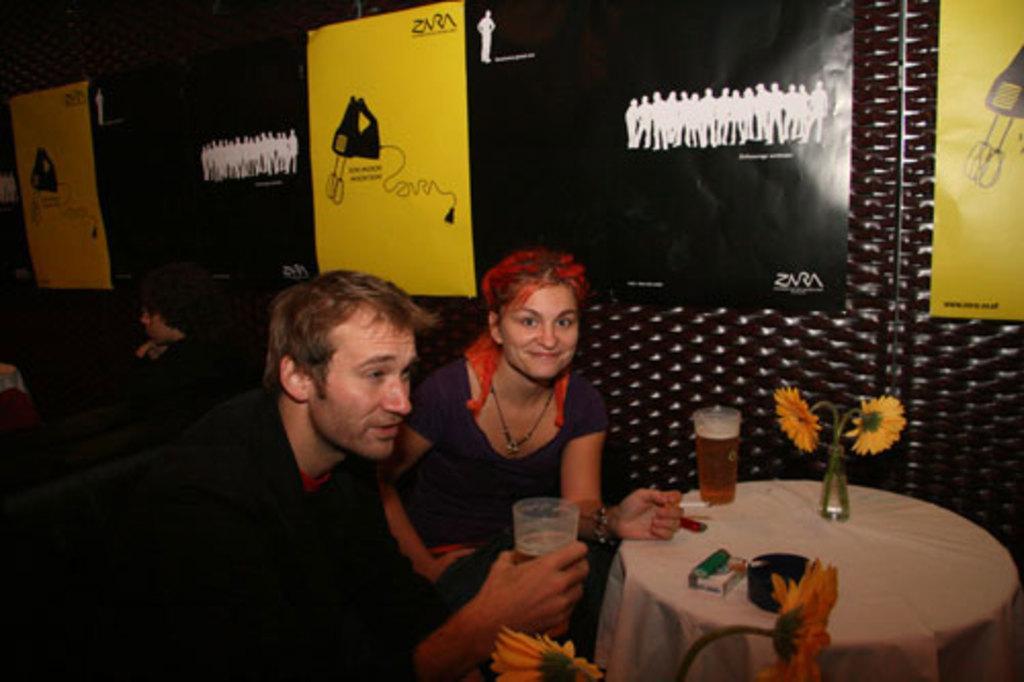Could you give a brief overview of what you see in this image? In this image I see a man and a woman who are sitting and I see that this woman is smiling and she is holding cigarette in her hand and this man is holding a glass in his hand and I see a table in front of them on which there is another class and flowers in a bottle and I can also see few flowers over here. In the background I see people and banners on the wall. 